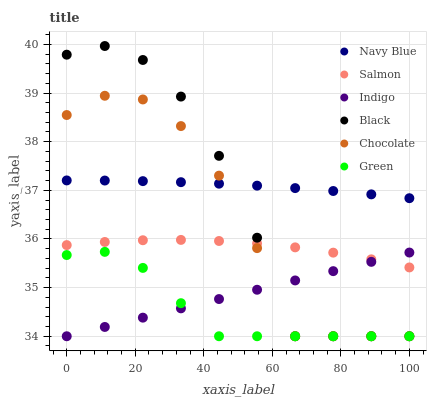Does Green have the minimum area under the curve?
Answer yes or no. Yes. Does Navy Blue have the maximum area under the curve?
Answer yes or no. Yes. Does Salmon have the minimum area under the curve?
Answer yes or no. No. Does Salmon have the maximum area under the curve?
Answer yes or no. No. Is Indigo the smoothest?
Answer yes or no. Yes. Is Black the roughest?
Answer yes or no. Yes. Is Navy Blue the smoothest?
Answer yes or no. No. Is Navy Blue the roughest?
Answer yes or no. No. Does Indigo have the lowest value?
Answer yes or no. Yes. Does Salmon have the lowest value?
Answer yes or no. No. Does Black have the highest value?
Answer yes or no. Yes. Does Navy Blue have the highest value?
Answer yes or no. No. Is Indigo less than Navy Blue?
Answer yes or no. Yes. Is Navy Blue greater than Green?
Answer yes or no. Yes. Does Black intersect Chocolate?
Answer yes or no. Yes. Is Black less than Chocolate?
Answer yes or no. No. Is Black greater than Chocolate?
Answer yes or no. No. Does Indigo intersect Navy Blue?
Answer yes or no. No. 